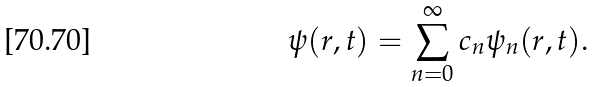<formula> <loc_0><loc_0><loc_500><loc_500>\psi ( r , t ) = \sum _ { n = 0 } ^ { \infty } c _ { n } \psi _ { n } ( r , t ) .</formula> 